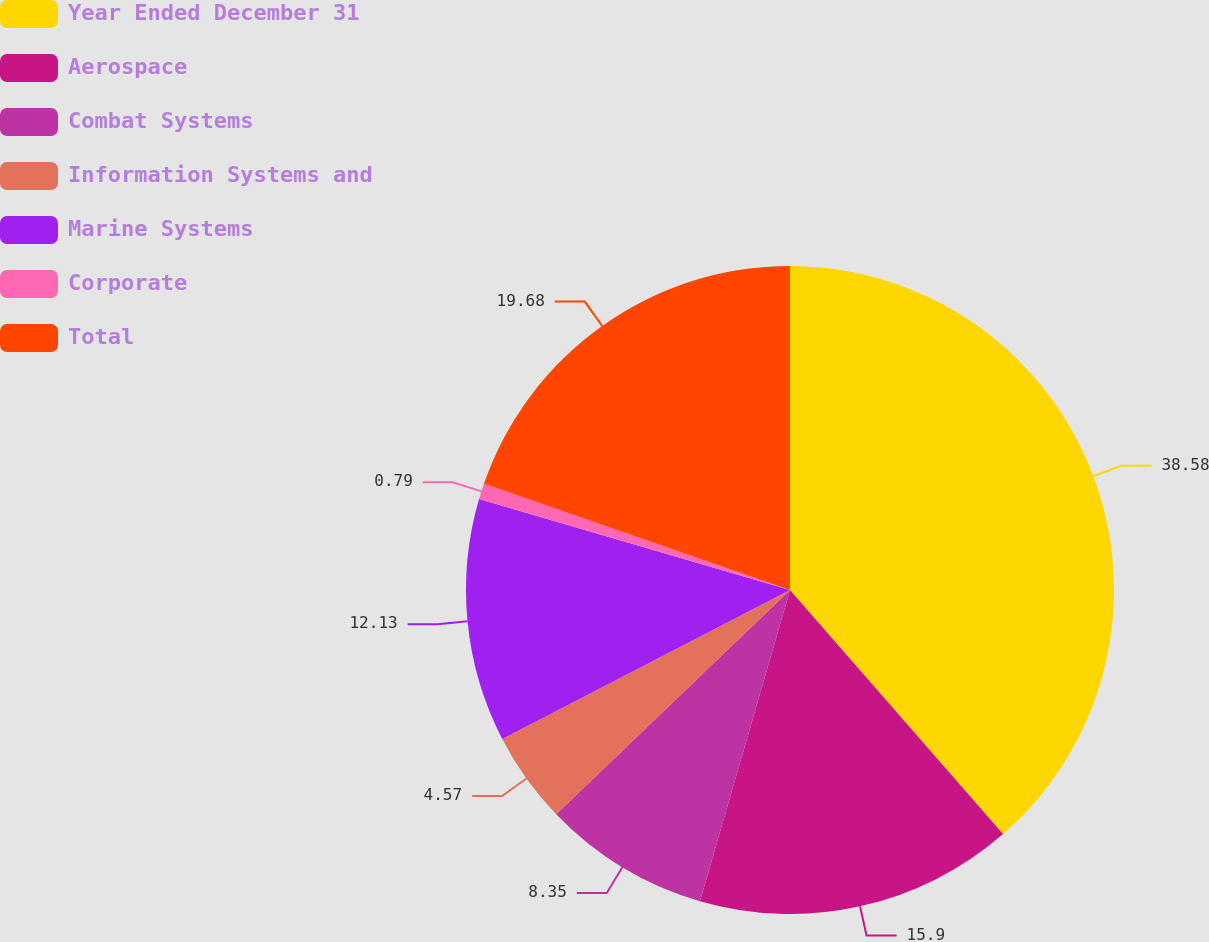Convert chart. <chart><loc_0><loc_0><loc_500><loc_500><pie_chart><fcel>Year Ended December 31<fcel>Aerospace<fcel>Combat Systems<fcel>Information Systems and<fcel>Marine Systems<fcel>Corporate<fcel>Total<nl><fcel>38.59%<fcel>15.91%<fcel>8.35%<fcel>4.57%<fcel>12.13%<fcel>0.79%<fcel>19.69%<nl></chart> 